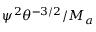Convert formula to latex. <formula><loc_0><loc_0><loc_500><loc_500>{ \psi } ^ { 2 } \theta ^ { - 3 / 2 } / M _ { a }</formula> 